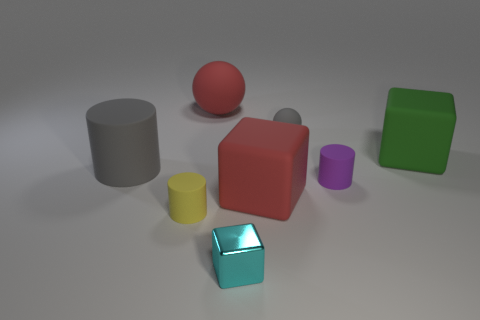What number of large blocks have the same color as the big matte ball?
Your response must be concise. 1. There is a small yellow rubber thing in front of the tiny cylinder that is to the right of the tiny cyan object; are there any spheres on the left side of it?
Give a very brief answer. No. There is a object that is on the right side of the tiny sphere and behind the purple cylinder; what is its size?
Provide a succinct answer. Large. What number of yellow things are made of the same material as the large gray cylinder?
Your answer should be very brief. 1. How many cylinders are purple objects or cyan things?
Offer a terse response. 1. There is a red cube that is left of the cube behind the cylinder on the left side of the yellow matte cylinder; what is its size?
Offer a terse response. Large. What is the color of the big thing that is behind the large cylinder and in front of the large red rubber ball?
Ensure brevity in your answer.  Green. Is the size of the red matte block the same as the block that is to the right of the small purple rubber cylinder?
Provide a succinct answer. Yes. Is there anything else that is the same shape as the cyan shiny thing?
Your response must be concise. Yes. There is another small thing that is the same shape as the green rubber thing; what is its color?
Make the answer very short. Cyan. 